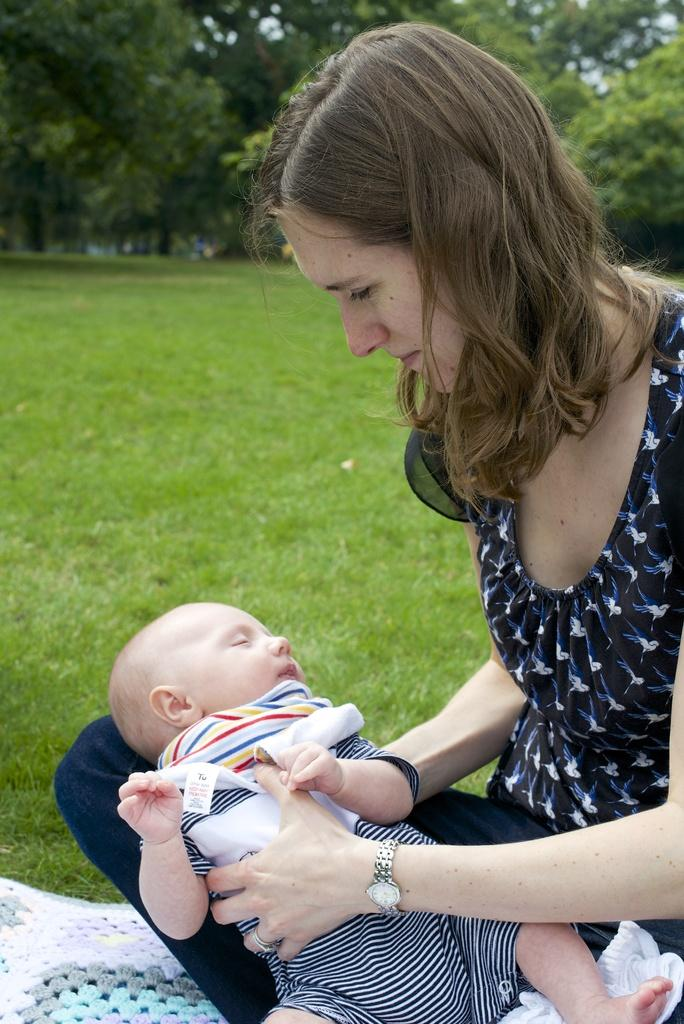Who is present in the image? There is a lady and a kid in the image. What is the setting of the image? The background of the image includes grass, trees, and the sky. Can you describe the location of the cloth in the image? The cloth is on the left side bottom of the image. How many cattle can be seen grazing in the image? There are no cattle present in the image. What type of kick is the hen performing in the image? There is no hen present in the image, and therefore no kicking can be observed. 